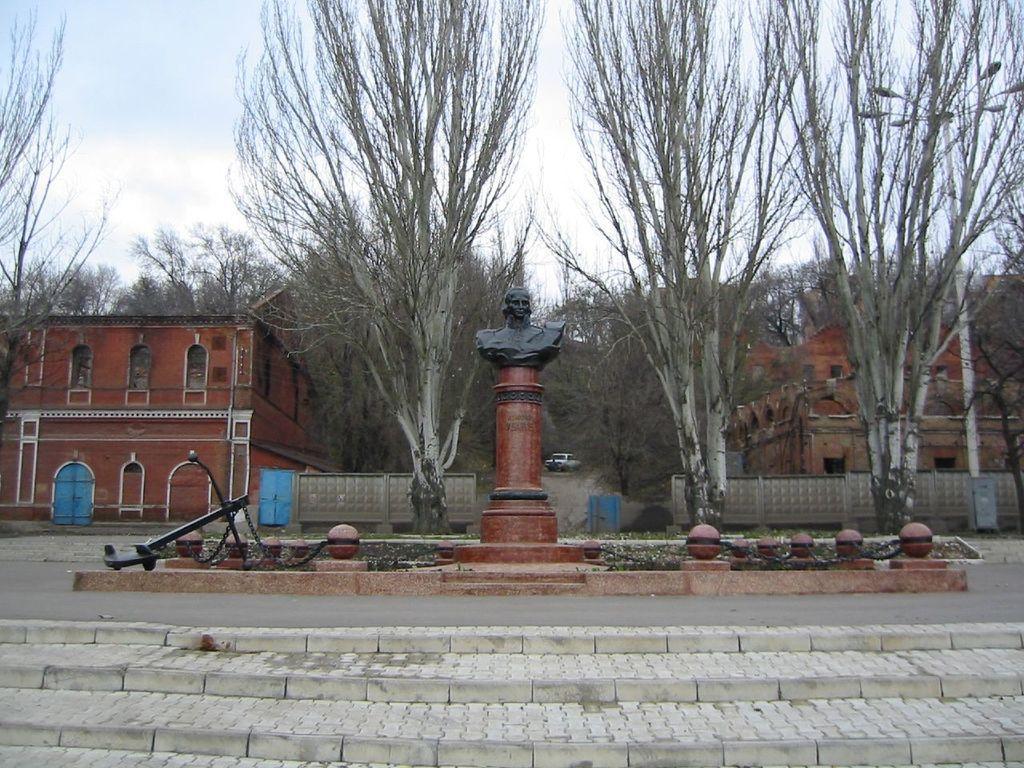Can you describe this image briefly? In this image there are buildings, trees, the sky, vehicle visible at the top, in the middle there is a pole, on which there is a sculpture, there are some other objects visible, at the bottom there is a road, steps visible. 